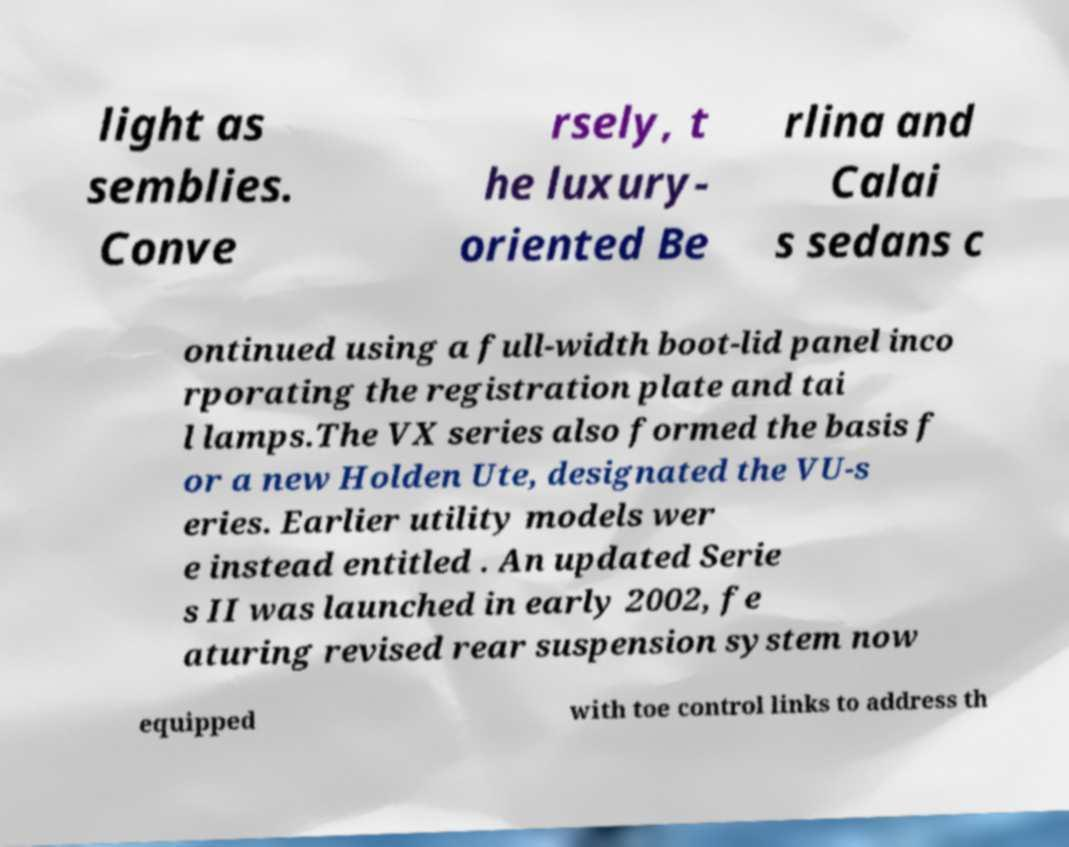Can you accurately transcribe the text from the provided image for me? light as semblies. Conve rsely, t he luxury- oriented Be rlina and Calai s sedans c ontinued using a full-width boot-lid panel inco rporating the registration plate and tai l lamps.The VX series also formed the basis f or a new Holden Ute, designated the VU-s eries. Earlier utility models wer e instead entitled . An updated Serie s II was launched in early 2002, fe aturing revised rear suspension system now equipped with toe control links to address th 